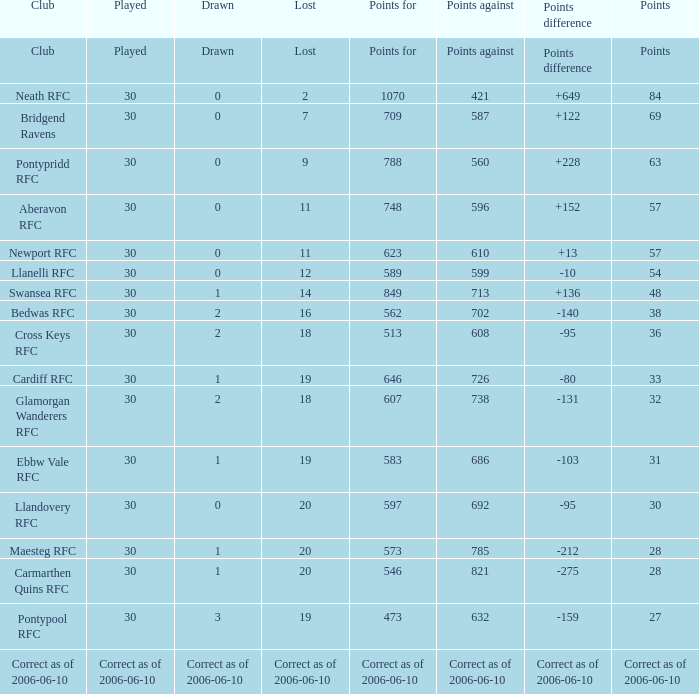What is Drawn, when Points Against is "686"? 1.0. 